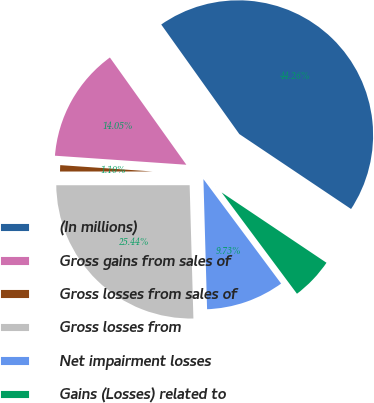Convert chart to OTSL. <chart><loc_0><loc_0><loc_500><loc_500><pie_chart><fcel>(In millions)<fcel>Gross gains from sales of<fcel>Gross losses from sales of<fcel>Gross losses from<fcel>Net impairment losses<fcel>Gains (Losses) related to<nl><fcel>44.26%<fcel>14.05%<fcel>1.1%<fcel>25.44%<fcel>9.73%<fcel>5.42%<nl></chart> 